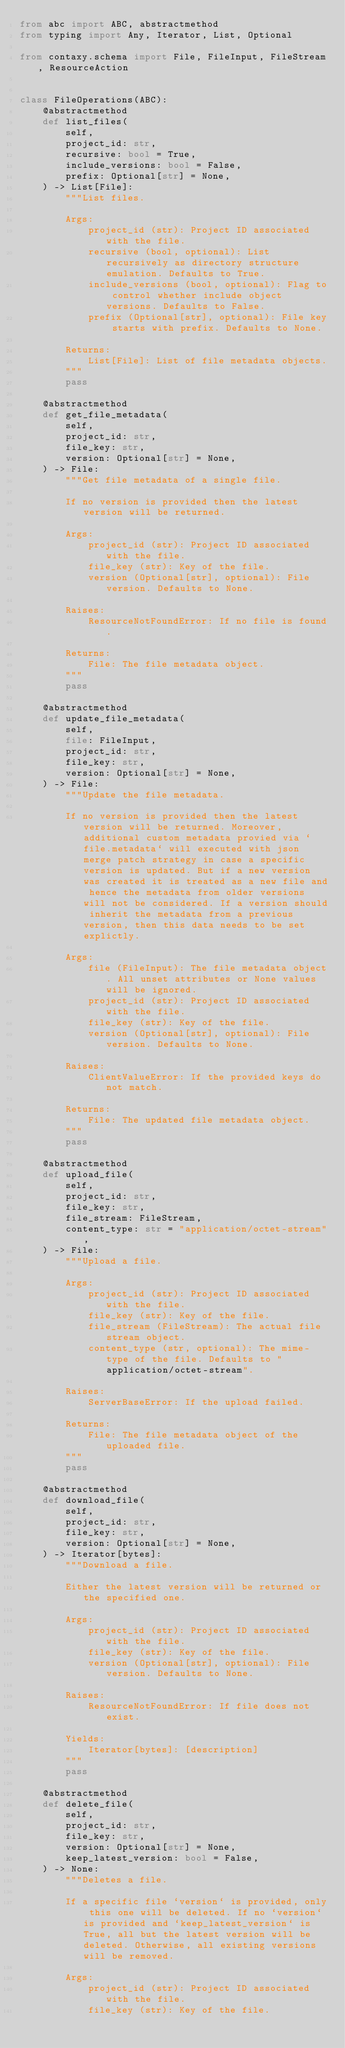Convert code to text. <code><loc_0><loc_0><loc_500><loc_500><_Python_>from abc import ABC, abstractmethod
from typing import Any, Iterator, List, Optional

from contaxy.schema import File, FileInput, FileStream, ResourceAction


class FileOperations(ABC):
    @abstractmethod
    def list_files(
        self,
        project_id: str,
        recursive: bool = True,
        include_versions: bool = False,
        prefix: Optional[str] = None,
    ) -> List[File]:
        """List files.

        Args:
            project_id (str): Project ID associated with the file.
            recursive (bool, optional): List recursively as directory structure emulation. Defaults to True.
            include_versions (bool, optional): Flag to control whether include object versions. Defaults to False.
            prefix (Optional[str], optional): File key starts with prefix. Defaults to None.

        Returns:
            List[File]: List of file metadata objects.
        """
        pass

    @abstractmethod
    def get_file_metadata(
        self,
        project_id: str,
        file_key: str,
        version: Optional[str] = None,
    ) -> File:
        """Get file metadata of a single file.

        If no version is provided then the latest version will be returned.

        Args:
            project_id (str): Project ID associated with the file.
            file_key (str): Key of the file.
            version (Optional[str], optional): File version. Defaults to None.

        Raises:
            ResourceNotFoundError: If no file is found.

        Returns:
            File: The file metadata object.
        """
        pass

    @abstractmethod
    def update_file_metadata(
        self,
        file: FileInput,
        project_id: str,
        file_key: str,
        version: Optional[str] = None,
    ) -> File:
        """Update the file metadata.

        If no version is provided then the latest version will be returned. Moreover, additional custom metadata provied via `file.metadata` will executed with json merge patch strategy in case a specific version is updated. But if a new version was created it is treated as a new file and hence the metadata from older versions will not be considered. If a version should inherit the metadata from a previous version, then this data needs to be set explictly.

        Args:
            file (FileInput): The file metadata object. All unset attributes or None values will be ignored.
            project_id (str): Project ID associated with the file.
            file_key (str): Key of the file.
            version (Optional[str], optional): File version. Defaults to None.

        Raises:
            ClientValueError: If the provided keys do not match.

        Returns:
            File: The updated file metadata object.
        """
        pass

    @abstractmethod
    def upload_file(
        self,
        project_id: str,
        file_key: str,
        file_stream: FileStream,
        content_type: str = "application/octet-stream",
    ) -> File:
        """Upload a file.

        Args:
            project_id (str): Project ID associated with the file.
            file_key (str): Key of the file.
            file_stream (FileStream): The actual file stream object.
            content_type (str, optional): The mime-type of the file. Defaults to "application/octet-stream".

        Raises:
            ServerBaseError: If the upload failed.

        Returns:
            File: The file metadata object of the uploaded file.
        """
        pass

    @abstractmethod
    def download_file(
        self,
        project_id: str,
        file_key: str,
        version: Optional[str] = None,
    ) -> Iterator[bytes]:
        """Download a file.

        Either the latest version will be returned or the specified one.

        Args:
            project_id (str): Project ID associated with the file.
            file_key (str): Key of the file.
            version (Optional[str], optional): File version. Defaults to None.

        Raises:
            ResourceNotFoundError: If file does not exist.

        Yields:
            Iterator[bytes]: [description]
        """
        pass

    @abstractmethod
    def delete_file(
        self,
        project_id: str,
        file_key: str,
        version: Optional[str] = None,
        keep_latest_version: bool = False,
    ) -> None:
        """Deletes a file.

        If a specific file `version` is provided, only this one will be deleted. If no `version` is provided and `keep_latest_version` is True, all but the latest version will be deleted. Otherwise, all existing versions will be removed.

        Args:
            project_id (str): Project ID associated with the file.
            file_key (str): Key of the file.</code> 